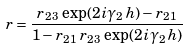Convert formula to latex. <formula><loc_0><loc_0><loc_500><loc_500>r = \frac { r _ { 2 3 } \, \exp ( 2 i \gamma _ { 2 } \, h ) - r _ { 2 1 } } { 1 - r _ { 2 1 } \, r _ { 2 3 } \, \exp ( 2 i \gamma _ { 2 } \, h ) }</formula> 